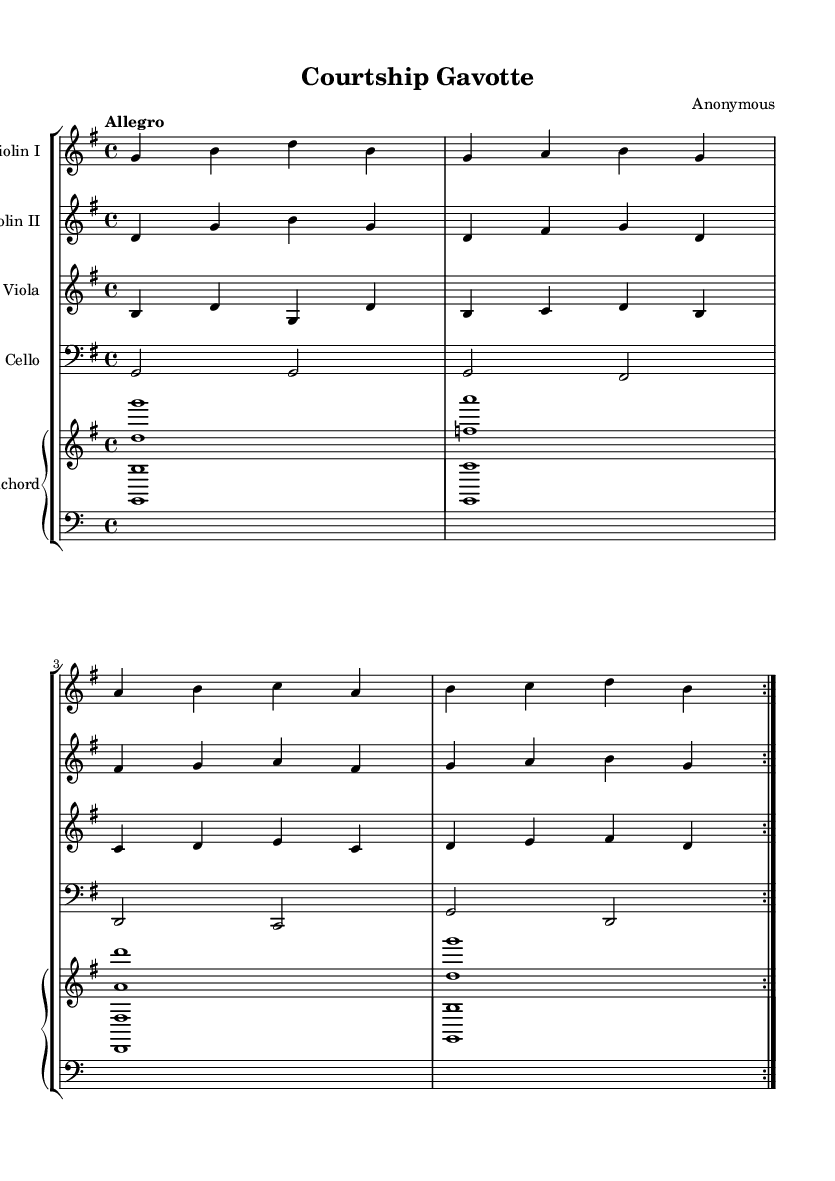What is the key signature of this music? The key signature shows one sharp, which indicates that the piece is in G major.
Answer: G major What is the time signature of this music? The time signature is indicated by the "4/4" at the start, meaning there are four beats in each measure and the quarter note gets one beat.
Answer: 4/4 What is the tempo marking of this piece? The tempo marking is "Allegro," which indicates a lively and fast pace for the music.
Answer: Allegro How many instruments are featured in this score? The score includes five distinct parts: two violins, one viola, one cello, and one harpsichord, totaling five instruments.
Answer: Five instruments Which instrument plays the bass line? The instrument playing the bass line is the cello, as it is written in the bass clef.
Answer: Cello What type of dance does this piece represent? The piece is a Gavotte, a type of lively dance popular in the Baroque era, indicated by its title "Courtship Gavotte."
Answer: Gavotte How does the structure of the music reflect Baroque characteristics? The music is characterized by the use of counterpoint between the two violins and the consistent rhythmic drive, typical features of Baroque dance suites.
Answer: Dance suite 